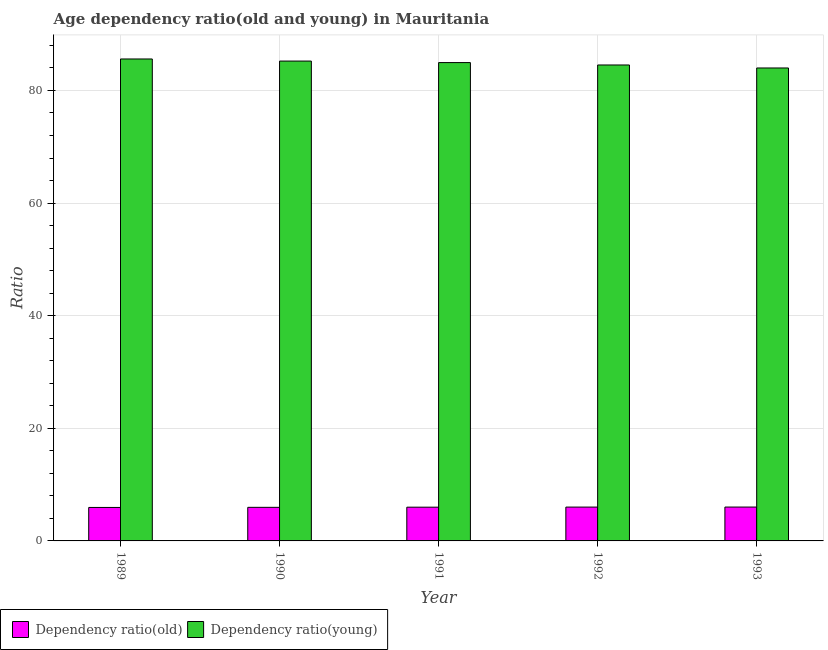How many bars are there on the 5th tick from the left?
Your response must be concise. 2. What is the label of the 4th group of bars from the left?
Offer a terse response. 1992. In how many cases, is the number of bars for a given year not equal to the number of legend labels?
Your answer should be compact. 0. What is the age dependency ratio(old) in 1989?
Give a very brief answer. 5.95. Across all years, what is the maximum age dependency ratio(young)?
Your response must be concise. 85.59. Across all years, what is the minimum age dependency ratio(old)?
Provide a short and direct response. 5.95. What is the total age dependency ratio(old) in the graph?
Make the answer very short. 29.92. What is the difference between the age dependency ratio(old) in 1989 and that in 1991?
Your answer should be compact. -0.05. What is the difference between the age dependency ratio(young) in 1992 and the age dependency ratio(old) in 1991?
Provide a short and direct response. -0.43. What is the average age dependency ratio(old) per year?
Make the answer very short. 5.98. In the year 1990, what is the difference between the age dependency ratio(old) and age dependency ratio(young)?
Offer a terse response. 0. What is the ratio of the age dependency ratio(young) in 1990 to that in 1993?
Offer a very short reply. 1.01. Is the age dependency ratio(old) in 1990 less than that in 1993?
Offer a very short reply. Yes. Is the difference between the age dependency ratio(young) in 1990 and 1993 greater than the difference between the age dependency ratio(old) in 1990 and 1993?
Your answer should be compact. No. What is the difference between the highest and the second highest age dependency ratio(old)?
Offer a very short reply. 0.01. What is the difference between the highest and the lowest age dependency ratio(old)?
Offer a terse response. 0.07. In how many years, is the age dependency ratio(old) greater than the average age dependency ratio(old) taken over all years?
Your answer should be very brief. 3. Is the sum of the age dependency ratio(old) in 1991 and 1993 greater than the maximum age dependency ratio(young) across all years?
Keep it short and to the point. Yes. What does the 1st bar from the left in 1992 represents?
Provide a short and direct response. Dependency ratio(old). What does the 1st bar from the right in 1993 represents?
Ensure brevity in your answer.  Dependency ratio(young). How many bars are there?
Provide a short and direct response. 10. Are all the bars in the graph horizontal?
Your answer should be very brief. No. Are the values on the major ticks of Y-axis written in scientific E-notation?
Keep it short and to the point. No. How many legend labels are there?
Your response must be concise. 2. How are the legend labels stacked?
Your answer should be very brief. Horizontal. What is the title of the graph?
Offer a very short reply. Age dependency ratio(old and young) in Mauritania. Does "Females" appear as one of the legend labels in the graph?
Make the answer very short. No. What is the label or title of the X-axis?
Your answer should be compact. Year. What is the label or title of the Y-axis?
Your answer should be compact. Ratio. What is the Ratio in Dependency ratio(old) in 1989?
Give a very brief answer. 5.95. What is the Ratio of Dependency ratio(young) in 1989?
Your answer should be very brief. 85.59. What is the Ratio of Dependency ratio(old) in 1990?
Give a very brief answer. 5.96. What is the Ratio in Dependency ratio(young) in 1990?
Offer a terse response. 85.22. What is the Ratio in Dependency ratio(old) in 1991?
Your answer should be very brief. 5.99. What is the Ratio of Dependency ratio(young) in 1991?
Keep it short and to the point. 84.95. What is the Ratio of Dependency ratio(old) in 1992?
Provide a short and direct response. 6.01. What is the Ratio in Dependency ratio(young) in 1992?
Your answer should be compact. 84.52. What is the Ratio of Dependency ratio(old) in 1993?
Offer a very short reply. 6.01. What is the Ratio of Dependency ratio(young) in 1993?
Provide a succinct answer. 83.99. Across all years, what is the maximum Ratio of Dependency ratio(old)?
Your answer should be compact. 6.01. Across all years, what is the maximum Ratio in Dependency ratio(young)?
Provide a short and direct response. 85.59. Across all years, what is the minimum Ratio of Dependency ratio(old)?
Provide a short and direct response. 5.95. Across all years, what is the minimum Ratio in Dependency ratio(young)?
Your response must be concise. 83.99. What is the total Ratio of Dependency ratio(old) in the graph?
Offer a very short reply. 29.92. What is the total Ratio of Dependency ratio(young) in the graph?
Provide a short and direct response. 424.28. What is the difference between the Ratio of Dependency ratio(old) in 1989 and that in 1990?
Provide a succinct answer. -0.02. What is the difference between the Ratio of Dependency ratio(young) in 1989 and that in 1990?
Ensure brevity in your answer.  0.37. What is the difference between the Ratio in Dependency ratio(old) in 1989 and that in 1991?
Give a very brief answer. -0.05. What is the difference between the Ratio of Dependency ratio(young) in 1989 and that in 1991?
Offer a terse response. 0.64. What is the difference between the Ratio of Dependency ratio(old) in 1989 and that in 1992?
Your answer should be very brief. -0.06. What is the difference between the Ratio of Dependency ratio(young) in 1989 and that in 1992?
Keep it short and to the point. 1.07. What is the difference between the Ratio in Dependency ratio(old) in 1989 and that in 1993?
Ensure brevity in your answer.  -0.07. What is the difference between the Ratio of Dependency ratio(young) in 1989 and that in 1993?
Your response must be concise. 1.6. What is the difference between the Ratio in Dependency ratio(old) in 1990 and that in 1991?
Ensure brevity in your answer.  -0.03. What is the difference between the Ratio in Dependency ratio(young) in 1990 and that in 1991?
Your response must be concise. 0.27. What is the difference between the Ratio of Dependency ratio(old) in 1990 and that in 1992?
Your response must be concise. -0.04. What is the difference between the Ratio of Dependency ratio(young) in 1990 and that in 1992?
Make the answer very short. 0.69. What is the difference between the Ratio of Dependency ratio(old) in 1990 and that in 1993?
Provide a short and direct response. -0.05. What is the difference between the Ratio in Dependency ratio(young) in 1990 and that in 1993?
Your response must be concise. 1.23. What is the difference between the Ratio in Dependency ratio(old) in 1991 and that in 1992?
Give a very brief answer. -0.02. What is the difference between the Ratio in Dependency ratio(young) in 1991 and that in 1992?
Ensure brevity in your answer.  0.43. What is the difference between the Ratio in Dependency ratio(old) in 1991 and that in 1993?
Provide a succinct answer. -0.02. What is the difference between the Ratio in Dependency ratio(young) in 1991 and that in 1993?
Ensure brevity in your answer.  0.96. What is the difference between the Ratio of Dependency ratio(old) in 1992 and that in 1993?
Your response must be concise. -0.01. What is the difference between the Ratio of Dependency ratio(young) in 1992 and that in 1993?
Offer a terse response. 0.53. What is the difference between the Ratio of Dependency ratio(old) in 1989 and the Ratio of Dependency ratio(young) in 1990?
Provide a short and direct response. -79.27. What is the difference between the Ratio in Dependency ratio(old) in 1989 and the Ratio in Dependency ratio(young) in 1991?
Offer a very short reply. -79.01. What is the difference between the Ratio of Dependency ratio(old) in 1989 and the Ratio of Dependency ratio(young) in 1992?
Your answer should be compact. -78.58. What is the difference between the Ratio in Dependency ratio(old) in 1989 and the Ratio in Dependency ratio(young) in 1993?
Your response must be concise. -78.05. What is the difference between the Ratio of Dependency ratio(old) in 1990 and the Ratio of Dependency ratio(young) in 1991?
Make the answer very short. -78.99. What is the difference between the Ratio in Dependency ratio(old) in 1990 and the Ratio in Dependency ratio(young) in 1992?
Ensure brevity in your answer.  -78.56. What is the difference between the Ratio of Dependency ratio(old) in 1990 and the Ratio of Dependency ratio(young) in 1993?
Your response must be concise. -78.03. What is the difference between the Ratio of Dependency ratio(old) in 1991 and the Ratio of Dependency ratio(young) in 1992?
Provide a succinct answer. -78.53. What is the difference between the Ratio in Dependency ratio(old) in 1991 and the Ratio in Dependency ratio(young) in 1993?
Ensure brevity in your answer.  -78. What is the difference between the Ratio in Dependency ratio(old) in 1992 and the Ratio in Dependency ratio(young) in 1993?
Offer a terse response. -77.99. What is the average Ratio of Dependency ratio(old) per year?
Ensure brevity in your answer.  5.98. What is the average Ratio of Dependency ratio(young) per year?
Your answer should be compact. 84.86. In the year 1989, what is the difference between the Ratio in Dependency ratio(old) and Ratio in Dependency ratio(young)?
Ensure brevity in your answer.  -79.65. In the year 1990, what is the difference between the Ratio in Dependency ratio(old) and Ratio in Dependency ratio(young)?
Make the answer very short. -79.26. In the year 1991, what is the difference between the Ratio of Dependency ratio(old) and Ratio of Dependency ratio(young)?
Provide a short and direct response. -78.96. In the year 1992, what is the difference between the Ratio of Dependency ratio(old) and Ratio of Dependency ratio(young)?
Ensure brevity in your answer.  -78.52. In the year 1993, what is the difference between the Ratio in Dependency ratio(old) and Ratio in Dependency ratio(young)?
Keep it short and to the point. -77.98. What is the ratio of the Ratio of Dependency ratio(old) in 1989 to that in 1990?
Provide a short and direct response. 1. What is the ratio of the Ratio of Dependency ratio(young) in 1989 to that in 1990?
Your answer should be very brief. 1. What is the ratio of the Ratio of Dependency ratio(young) in 1989 to that in 1991?
Provide a short and direct response. 1.01. What is the ratio of the Ratio of Dependency ratio(old) in 1989 to that in 1992?
Make the answer very short. 0.99. What is the ratio of the Ratio in Dependency ratio(young) in 1989 to that in 1992?
Ensure brevity in your answer.  1.01. What is the ratio of the Ratio of Dependency ratio(young) in 1990 to that in 1992?
Your answer should be very brief. 1.01. What is the ratio of the Ratio of Dependency ratio(young) in 1990 to that in 1993?
Your answer should be compact. 1.01. What is the ratio of the Ratio of Dependency ratio(young) in 1991 to that in 1992?
Offer a terse response. 1. What is the ratio of the Ratio in Dependency ratio(young) in 1991 to that in 1993?
Make the answer very short. 1.01. What is the ratio of the Ratio in Dependency ratio(old) in 1992 to that in 1993?
Your answer should be compact. 1. What is the difference between the highest and the second highest Ratio of Dependency ratio(old)?
Make the answer very short. 0.01. What is the difference between the highest and the second highest Ratio of Dependency ratio(young)?
Keep it short and to the point. 0.37. What is the difference between the highest and the lowest Ratio of Dependency ratio(old)?
Offer a very short reply. 0.07. What is the difference between the highest and the lowest Ratio in Dependency ratio(young)?
Offer a terse response. 1.6. 